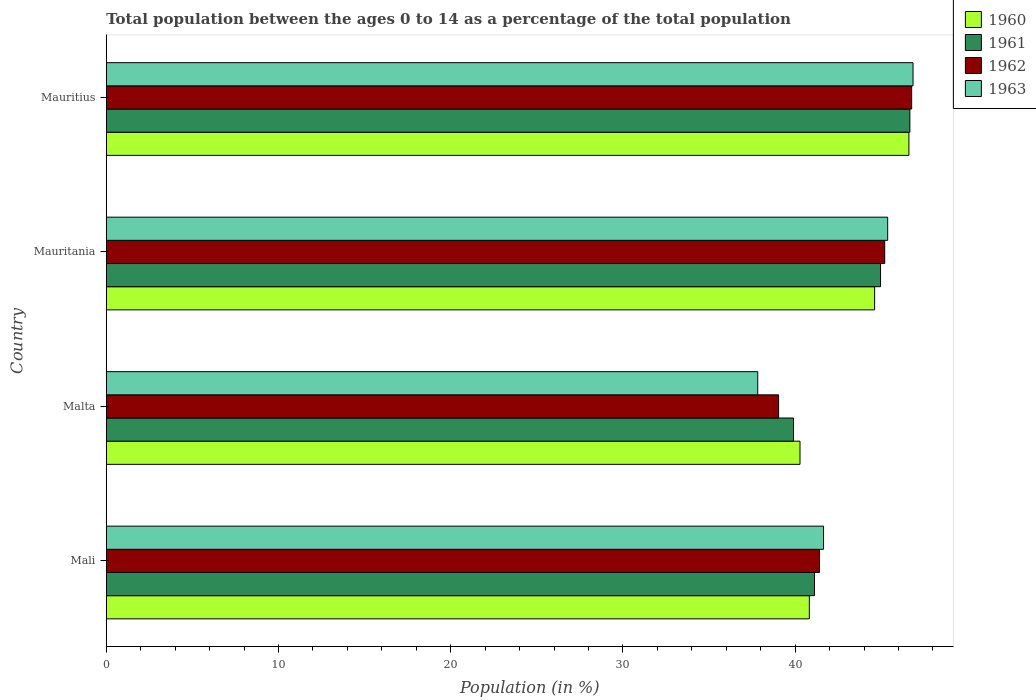How many groups of bars are there?
Provide a succinct answer. 4. Are the number of bars on each tick of the Y-axis equal?
Your response must be concise. Yes. How many bars are there on the 2nd tick from the top?
Provide a succinct answer. 4. What is the label of the 3rd group of bars from the top?
Provide a succinct answer. Malta. What is the percentage of the population ages 0 to 14 in 1960 in Malta?
Your answer should be very brief. 40.28. Across all countries, what is the maximum percentage of the population ages 0 to 14 in 1962?
Make the answer very short. 46.76. Across all countries, what is the minimum percentage of the population ages 0 to 14 in 1963?
Ensure brevity in your answer.  37.83. In which country was the percentage of the population ages 0 to 14 in 1962 maximum?
Offer a very short reply. Mauritius. In which country was the percentage of the population ages 0 to 14 in 1963 minimum?
Provide a succinct answer. Malta. What is the total percentage of the population ages 0 to 14 in 1963 in the graph?
Make the answer very short. 171.7. What is the difference between the percentage of the population ages 0 to 14 in 1963 in Mauritania and that in Mauritius?
Keep it short and to the point. -1.47. What is the difference between the percentage of the population ages 0 to 14 in 1963 in Mauritania and the percentage of the population ages 0 to 14 in 1962 in Mali?
Give a very brief answer. 3.96. What is the average percentage of the population ages 0 to 14 in 1963 per country?
Keep it short and to the point. 42.92. What is the difference between the percentage of the population ages 0 to 14 in 1962 and percentage of the population ages 0 to 14 in 1963 in Mauritania?
Give a very brief answer. -0.17. What is the ratio of the percentage of the population ages 0 to 14 in 1960 in Malta to that in Mauritania?
Offer a terse response. 0.9. Is the percentage of the population ages 0 to 14 in 1963 in Mali less than that in Mauritania?
Keep it short and to the point. Yes. Is the difference between the percentage of the population ages 0 to 14 in 1962 in Mali and Malta greater than the difference between the percentage of the population ages 0 to 14 in 1963 in Mali and Malta?
Provide a short and direct response. No. What is the difference between the highest and the second highest percentage of the population ages 0 to 14 in 1963?
Offer a terse response. 1.47. What is the difference between the highest and the lowest percentage of the population ages 0 to 14 in 1960?
Your answer should be very brief. 6.32. In how many countries, is the percentage of the population ages 0 to 14 in 1962 greater than the average percentage of the population ages 0 to 14 in 1962 taken over all countries?
Your response must be concise. 2. Is the sum of the percentage of the population ages 0 to 14 in 1962 in Mali and Mauritius greater than the maximum percentage of the population ages 0 to 14 in 1960 across all countries?
Your answer should be very brief. Yes. Is it the case that in every country, the sum of the percentage of the population ages 0 to 14 in 1960 and percentage of the population ages 0 to 14 in 1963 is greater than the sum of percentage of the population ages 0 to 14 in 1962 and percentage of the population ages 0 to 14 in 1961?
Your answer should be compact. No. Is it the case that in every country, the sum of the percentage of the population ages 0 to 14 in 1961 and percentage of the population ages 0 to 14 in 1960 is greater than the percentage of the population ages 0 to 14 in 1963?
Your answer should be compact. Yes. How many bars are there?
Offer a terse response. 16. How many countries are there in the graph?
Keep it short and to the point. 4. Are the values on the major ticks of X-axis written in scientific E-notation?
Make the answer very short. No. Where does the legend appear in the graph?
Provide a short and direct response. Top right. How many legend labels are there?
Provide a succinct answer. 4. How are the legend labels stacked?
Provide a short and direct response. Vertical. What is the title of the graph?
Your answer should be very brief. Total population between the ages 0 to 14 as a percentage of the total population. What is the label or title of the Y-axis?
Ensure brevity in your answer.  Country. What is the Population (in %) of 1960 in Mali?
Your answer should be very brief. 40.82. What is the Population (in %) in 1961 in Mali?
Ensure brevity in your answer.  41.12. What is the Population (in %) in 1962 in Mali?
Keep it short and to the point. 41.41. What is the Population (in %) of 1963 in Mali?
Ensure brevity in your answer.  41.65. What is the Population (in %) in 1960 in Malta?
Give a very brief answer. 40.28. What is the Population (in %) of 1961 in Malta?
Make the answer very short. 39.91. What is the Population (in %) in 1962 in Malta?
Your answer should be compact. 39.04. What is the Population (in %) in 1963 in Malta?
Ensure brevity in your answer.  37.83. What is the Population (in %) in 1960 in Mauritania?
Your answer should be compact. 44.61. What is the Population (in %) of 1961 in Mauritania?
Ensure brevity in your answer.  44.96. What is the Population (in %) in 1962 in Mauritania?
Keep it short and to the point. 45.2. What is the Population (in %) of 1963 in Mauritania?
Offer a terse response. 45.37. What is the Population (in %) of 1960 in Mauritius?
Keep it short and to the point. 46.61. What is the Population (in %) of 1961 in Mauritius?
Offer a terse response. 46.66. What is the Population (in %) in 1962 in Mauritius?
Offer a very short reply. 46.76. What is the Population (in %) of 1963 in Mauritius?
Provide a succinct answer. 46.84. Across all countries, what is the maximum Population (in %) of 1960?
Make the answer very short. 46.61. Across all countries, what is the maximum Population (in %) of 1961?
Your answer should be very brief. 46.66. Across all countries, what is the maximum Population (in %) of 1962?
Offer a very short reply. 46.76. Across all countries, what is the maximum Population (in %) in 1963?
Keep it short and to the point. 46.84. Across all countries, what is the minimum Population (in %) of 1960?
Ensure brevity in your answer.  40.28. Across all countries, what is the minimum Population (in %) in 1961?
Your answer should be very brief. 39.91. Across all countries, what is the minimum Population (in %) in 1962?
Your response must be concise. 39.04. Across all countries, what is the minimum Population (in %) of 1963?
Your response must be concise. 37.83. What is the total Population (in %) in 1960 in the graph?
Your answer should be very brief. 172.33. What is the total Population (in %) of 1961 in the graph?
Provide a succinct answer. 172.65. What is the total Population (in %) in 1962 in the graph?
Give a very brief answer. 172.41. What is the total Population (in %) of 1963 in the graph?
Provide a short and direct response. 171.7. What is the difference between the Population (in %) of 1960 in Mali and that in Malta?
Make the answer very short. 0.54. What is the difference between the Population (in %) in 1961 in Mali and that in Malta?
Your answer should be very brief. 1.22. What is the difference between the Population (in %) of 1962 in Mali and that in Malta?
Make the answer very short. 2.37. What is the difference between the Population (in %) in 1963 in Mali and that in Malta?
Your response must be concise. 3.82. What is the difference between the Population (in %) in 1960 in Mali and that in Mauritania?
Your answer should be compact. -3.79. What is the difference between the Population (in %) in 1961 in Mali and that in Mauritania?
Your answer should be compact. -3.83. What is the difference between the Population (in %) of 1962 in Mali and that in Mauritania?
Provide a succinct answer. -3.79. What is the difference between the Population (in %) of 1963 in Mali and that in Mauritania?
Your answer should be compact. -3.72. What is the difference between the Population (in %) in 1960 in Mali and that in Mauritius?
Ensure brevity in your answer.  -5.78. What is the difference between the Population (in %) of 1961 in Mali and that in Mauritius?
Offer a terse response. -5.54. What is the difference between the Population (in %) of 1962 in Mali and that in Mauritius?
Keep it short and to the point. -5.36. What is the difference between the Population (in %) in 1963 in Mali and that in Mauritius?
Provide a succinct answer. -5.2. What is the difference between the Population (in %) in 1960 in Malta and that in Mauritania?
Keep it short and to the point. -4.33. What is the difference between the Population (in %) of 1961 in Malta and that in Mauritania?
Provide a short and direct response. -5.05. What is the difference between the Population (in %) of 1962 in Malta and that in Mauritania?
Offer a terse response. -6.16. What is the difference between the Population (in %) of 1963 in Malta and that in Mauritania?
Ensure brevity in your answer.  -7.54. What is the difference between the Population (in %) in 1960 in Malta and that in Mauritius?
Your response must be concise. -6.32. What is the difference between the Population (in %) in 1961 in Malta and that in Mauritius?
Keep it short and to the point. -6.75. What is the difference between the Population (in %) in 1962 in Malta and that in Mauritius?
Give a very brief answer. -7.72. What is the difference between the Population (in %) of 1963 in Malta and that in Mauritius?
Your answer should be very brief. -9.02. What is the difference between the Population (in %) in 1960 in Mauritania and that in Mauritius?
Ensure brevity in your answer.  -1.99. What is the difference between the Population (in %) of 1961 in Mauritania and that in Mauritius?
Provide a succinct answer. -1.7. What is the difference between the Population (in %) of 1962 in Mauritania and that in Mauritius?
Offer a terse response. -1.56. What is the difference between the Population (in %) in 1963 in Mauritania and that in Mauritius?
Ensure brevity in your answer.  -1.47. What is the difference between the Population (in %) in 1960 in Mali and the Population (in %) in 1961 in Malta?
Provide a short and direct response. 0.92. What is the difference between the Population (in %) in 1960 in Mali and the Population (in %) in 1962 in Malta?
Offer a very short reply. 1.78. What is the difference between the Population (in %) in 1960 in Mali and the Population (in %) in 1963 in Malta?
Your response must be concise. 3. What is the difference between the Population (in %) in 1961 in Mali and the Population (in %) in 1962 in Malta?
Provide a succinct answer. 2.08. What is the difference between the Population (in %) of 1961 in Mali and the Population (in %) of 1963 in Malta?
Your response must be concise. 3.29. What is the difference between the Population (in %) of 1962 in Mali and the Population (in %) of 1963 in Malta?
Give a very brief answer. 3.58. What is the difference between the Population (in %) in 1960 in Mali and the Population (in %) in 1961 in Mauritania?
Keep it short and to the point. -4.13. What is the difference between the Population (in %) in 1960 in Mali and the Population (in %) in 1962 in Mauritania?
Offer a very short reply. -4.38. What is the difference between the Population (in %) in 1960 in Mali and the Population (in %) in 1963 in Mauritania?
Offer a very short reply. -4.55. What is the difference between the Population (in %) of 1961 in Mali and the Population (in %) of 1962 in Mauritania?
Your answer should be compact. -4.08. What is the difference between the Population (in %) of 1961 in Mali and the Population (in %) of 1963 in Mauritania?
Provide a succinct answer. -4.25. What is the difference between the Population (in %) of 1962 in Mali and the Population (in %) of 1963 in Mauritania?
Your answer should be very brief. -3.96. What is the difference between the Population (in %) of 1960 in Mali and the Population (in %) of 1961 in Mauritius?
Ensure brevity in your answer.  -5.84. What is the difference between the Population (in %) in 1960 in Mali and the Population (in %) in 1962 in Mauritius?
Your answer should be very brief. -5.94. What is the difference between the Population (in %) of 1960 in Mali and the Population (in %) of 1963 in Mauritius?
Offer a terse response. -6.02. What is the difference between the Population (in %) in 1961 in Mali and the Population (in %) in 1962 in Mauritius?
Make the answer very short. -5.64. What is the difference between the Population (in %) of 1961 in Mali and the Population (in %) of 1963 in Mauritius?
Provide a short and direct response. -5.72. What is the difference between the Population (in %) of 1962 in Mali and the Population (in %) of 1963 in Mauritius?
Provide a short and direct response. -5.44. What is the difference between the Population (in %) in 1960 in Malta and the Population (in %) in 1961 in Mauritania?
Your answer should be very brief. -4.68. What is the difference between the Population (in %) of 1960 in Malta and the Population (in %) of 1962 in Mauritania?
Your response must be concise. -4.92. What is the difference between the Population (in %) of 1960 in Malta and the Population (in %) of 1963 in Mauritania?
Provide a succinct answer. -5.09. What is the difference between the Population (in %) in 1961 in Malta and the Population (in %) in 1962 in Mauritania?
Make the answer very short. -5.29. What is the difference between the Population (in %) of 1961 in Malta and the Population (in %) of 1963 in Mauritania?
Ensure brevity in your answer.  -5.47. What is the difference between the Population (in %) in 1962 in Malta and the Population (in %) in 1963 in Mauritania?
Provide a short and direct response. -6.33. What is the difference between the Population (in %) in 1960 in Malta and the Population (in %) in 1961 in Mauritius?
Make the answer very short. -6.38. What is the difference between the Population (in %) of 1960 in Malta and the Population (in %) of 1962 in Mauritius?
Offer a very short reply. -6.48. What is the difference between the Population (in %) in 1960 in Malta and the Population (in %) in 1963 in Mauritius?
Ensure brevity in your answer.  -6.56. What is the difference between the Population (in %) in 1961 in Malta and the Population (in %) in 1962 in Mauritius?
Provide a short and direct response. -6.86. What is the difference between the Population (in %) of 1961 in Malta and the Population (in %) of 1963 in Mauritius?
Your response must be concise. -6.94. What is the difference between the Population (in %) in 1962 in Malta and the Population (in %) in 1963 in Mauritius?
Your answer should be very brief. -7.8. What is the difference between the Population (in %) of 1960 in Mauritania and the Population (in %) of 1961 in Mauritius?
Your answer should be very brief. -2.05. What is the difference between the Population (in %) of 1960 in Mauritania and the Population (in %) of 1962 in Mauritius?
Keep it short and to the point. -2.15. What is the difference between the Population (in %) of 1960 in Mauritania and the Population (in %) of 1963 in Mauritius?
Provide a short and direct response. -2.23. What is the difference between the Population (in %) of 1961 in Mauritania and the Population (in %) of 1962 in Mauritius?
Ensure brevity in your answer.  -1.81. What is the difference between the Population (in %) of 1961 in Mauritania and the Population (in %) of 1963 in Mauritius?
Offer a terse response. -1.89. What is the difference between the Population (in %) of 1962 in Mauritania and the Population (in %) of 1963 in Mauritius?
Keep it short and to the point. -1.64. What is the average Population (in %) of 1960 per country?
Your response must be concise. 43.08. What is the average Population (in %) of 1961 per country?
Keep it short and to the point. 43.16. What is the average Population (in %) in 1962 per country?
Provide a short and direct response. 43.1. What is the average Population (in %) of 1963 per country?
Your response must be concise. 42.92. What is the difference between the Population (in %) of 1960 and Population (in %) of 1961 in Mali?
Your response must be concise. -0.3. What is the difference between the Population (in %) in 1960 and Population (in %) in 1962 in Mali?
Offer a terse response. -0.58. What is the difference between the Population (in %) in 1960 and Population (in %) in 1963 in Mali?
Offer a very short reply. -0.82. What is the difference between the Population (in %) of 1961 and Population (in %) of 1962 in Mali?
Offer a terse response. -0.29. What is the difference between the Population (in %) in 1961 and Population (in %) in 1963 in Mali?
Ensure brevity in your answer.  -0.53. What is the difference between the Population (in %) in 1962 and Population (in %) in 1963 in Mali?
Ensure brevity in your answer.  -0.24. What is the difference between the Population (in %) of 1960 and Population (in %) of 1961 in Malta?
Provide a short and direct response. 0.37. What is the difference between the Population (in %) in 1960 and Population (in %) in 1962 in Malta?
Offer a terse response. 1.24. What is the difference between the Population (in %) of 1960 and Population (in %) of 1963 in Malta?
Give a very brief answer. 2.45. What is the difference between the Population (in %) of 1961 and Population (in %) of 1962 in Malta?
Provide a short and direct response. 0.87. What is the difference between the Population (in %) of 1961 and Population (in %) of 1963 in Malta?
Ensure brevity in your answer.  2.08. What is the difference between the Population (in %) of 1962 and Population (in %) of 1963 in Malta?
Make the answer very short. 1.21. What is the difference between the Population (in %) in 1960 and Population (in %) in 1961 in Mauritania?
Ensure brevity in your answer.  -0.34. What is the difference between the Population (in %) in 1960 and Population (in %) in 1962 in Mauritania?
Provide a succinct answer. -0.59. What is the difference between the Population (in %) of 1960 and Population (in %) of 1963 in Mauritania?
Provide a succinct answer. -0.76. What is the difference between the Population (in %) of 1961 and Population (in %) of 1962 in Mauritania?
Make the answer very short. -0.24. What is the difference between the Population (in %) of 1961 and Population (in %) of 1963 in Mauritania?
Your answer should be compact. -0.42. What is the difference between the Population (in %) in 1962 and Population (in %) in 1963 in Mauritania?
Make the answer very short. -0.17. What is the difference between the Population (in %) in 1960 and Population (in %) in 1961 in Mauritius?
Your response must be concise. -0.06. What is the difference between the Population (in %) of 1960 and Population (in %) of 1962 in Mauritius?
Provide a short and direct response. -0.16. What is the difference between the Population (in %) of 1960 and Population (in %) of 1963 in Mauritius?
Your answer should be very brief. -0.24. What is the difference between the Population (in %) of 1961 and Population (in %) of 1962 in Mauritius?
Give a very brief answer. -0.1. What is the difference between the Population (in %) of 1961 and Population (in %) of 1963 in Mauritius?
Your answer should be very brief. -0.18. What is the difference between the Population (in %) in 1962 and Population (in %) in 1963 in Mauritius?
Ensure brevity in your answer.  -0.08. What is the ratio of the Population (in %) of 1960 in Mali to that in Malta?
Offer a very short reply. 1.01. What is the ratio of the Population (in %) in 1961 in Mali to that in Malta?
Your response must be concise. 1.03. What is the ratio of the Population (in %) of 1962 in Mali to that in Malta?
Your answer should be very brief. 1.06. What is the ratio of the Population (in %) of 1963 in Mali to that in Malta?
Your answer should be very brief. 1.1. What is the ratio of the Population (in %) in 1960 in Mali to that in Mauritania?
Your answer should be very brief. 0.92. What is the ratio of the Population (in %) in 1961 in Mali to that in Mauritania?
Offer a terse response. 0.91. What is the ratio of the Population (in %) of 1962 in Mali to that in Mauritania?
Offer a very short reply. 0.92. What is the ratio of the Population (in %) of 1963 in Mali to that in Mauritania?
Offer a very short reply. 0.92. What is the ratio of the Population (in %) in 1960 in Mali to that in Mauritius?
Offer a very short reply. 0.88. What is the ratio of the Population (in %) in 1961 in Mali to that in Mauritius?
Your answer should be compact. 0.88. What is the ratio of the Population (in %) in 1962 in Mali to that in Mauritius?
Keep it short and to the point. 0.89. What is the ratio of the Population (in %) in 1963 in Mali to that in Mauritius?
Your response must be concise. 0.89. What is the ratio of the Population (in %) of 1960 in Malta to that in Mauritania?
Your answer should be very brief. 0.9. What is the ratio of the Population (in %) in 1961 in Malta to that in Mauritania?
Your answer should be compact. 0.89. What is the ratio of the Population (in %) of 1962 in Malta to that in Mauritania?
Your response must be concise. 0.86. What is the ratio of the Population (in %) of 1963 in Malta to that in Mauritania?
Your answer should be compact. 0.83. What is the ratio of the Population (in %) in 1960 in Malta to that in Mauritius?
Make the answer very short. 0.86. What is the ratio of the Population (in %) in 1961 in Malta to that in Mauritius?
Your response must be concise. 0.86. What is the ratio of the Population (in %) of 1962 in Malta to that in Mauritius?
Provide a succinct answer. 0.83. What is the ratio of the Population (in %) of 1963 in Malta to that in Mauritius?
Offer a terse response. 0.81. What is the ratio of the Population (in %) of 1960 in Mauritania to that in Mauritius?
Keep it short and to the point. 0.96. What is the ratio of the Population (in %) in 1961 in Mauritania to that in Mauritius?
Your answer should be compact. 0.96. What is the ratio of the Population (in %) in 1962 in Mauritania to that in Mauritius?
Keep it short and to the point. 0.97. What is the ratio of the Population (in %) in 1963 in Mauritania to that in Mauritius?
Provide a short and direct response. 0.97. What is the difference between the highest and the second highest Population (in %) in 1960?
Your answer should be very brief. 1.99. What is the difference between the highest and the second highest Population (in %) of 1961?
Keep it short and to the point. 1.7. What is the difference between the highest and the second highest Population (in %) in 1962?
Provide a short and direct response. 1.56. What is the difference between the highest and the second highest Population (in %) of 1963?
Ensure brevity in your answer.  1.47. What is the difference between the highest and the lowest Population (in %) in 1960?
Your answer should be compact. 6.32. What is the difference between the highest and the lowest Population (in %) of 1961?
Make the answer very short. 6.75. What is the difference between the highest and the lowest Population (in %) in 1962?
Keep it short and to the point. 7.72. What is the difference between the highest and the lowest Population (in %) of 1963?
Give a very brief answer. 9.02. 